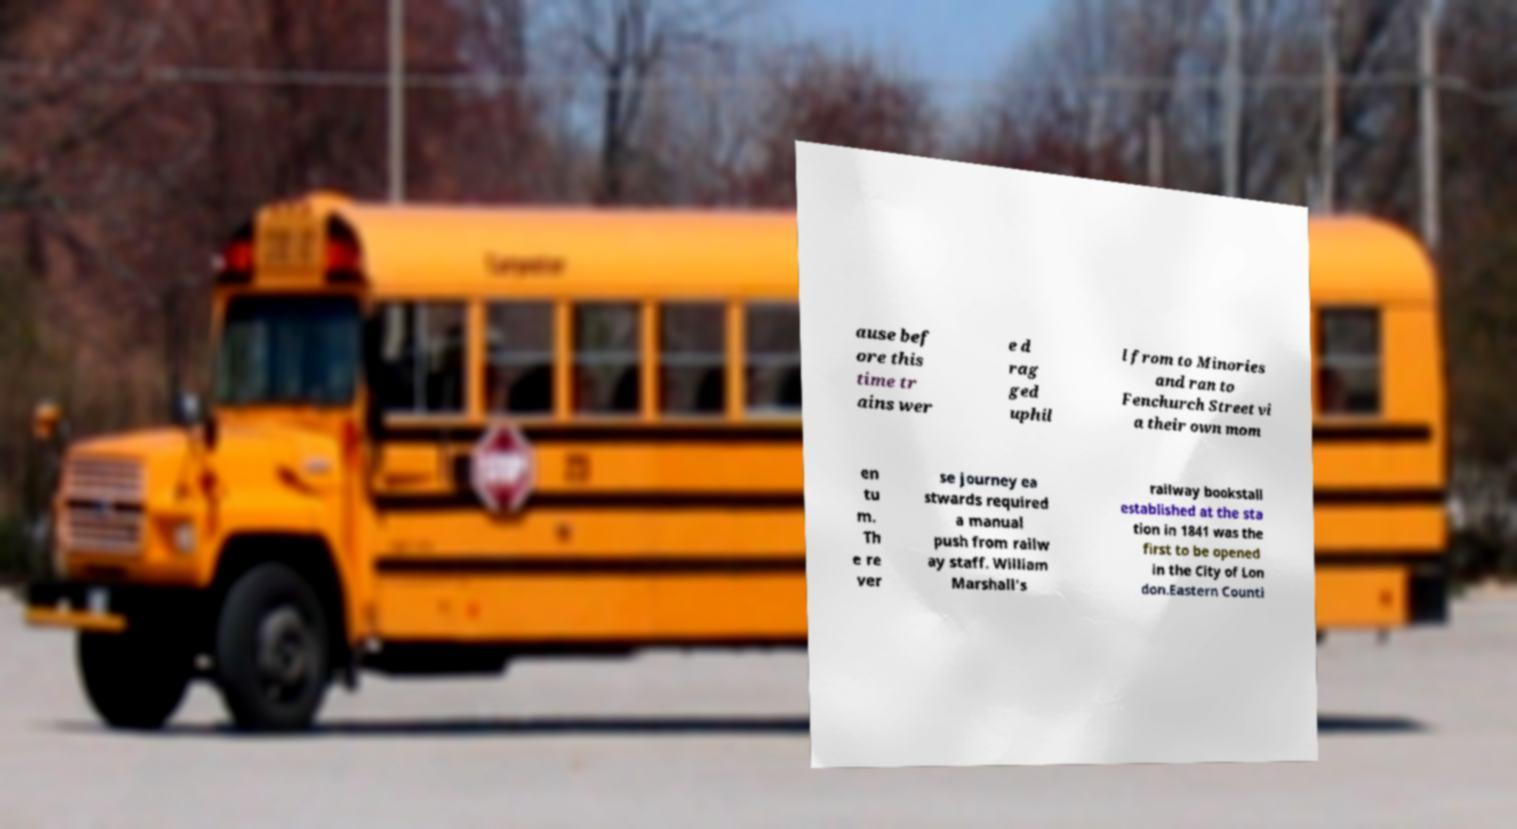Can you read and provide the text displayed in the image?This photo seems to have some interesting text. Can you extract and type it out for me? ause bef ore this time tr ains wer e d rag ged uphil l from to Minories and ran to Fenchurch Street vi a their own mom en tu m. Th e re ver se journey ea stwards required a manual push from railw ay staff. William Marshall's railway bookstall established at the sta tion in 1841 was the first to be opened in the City of Lon don.Eastern Counti 